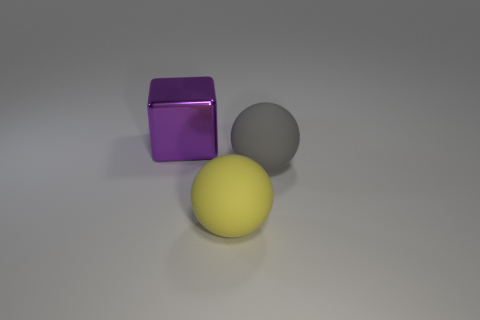How many other objects are there of the same material as the large purple block?
Give a very brief answer. 0. Does the big ball that is on the left side of the large gray ball have the same material as the big gray thing?
Keep it short and to the point. Yes. Are there more large spheres that are left of the yellow ball than purple things that are behind the purple metallic cube?
Keep it short and to the point. No. What number of objects are either large objects that are to the right of the large purple metallic cube or big objects?
Provide a succinct answer. 3. What shape is the big yellow thing that is the same material as the large gray object?
Your answer should be very brief. Sphere. Is there any other thing that is the same shape as the big yellow object?
Your answer should be compact. Yes. There is a large thing that is to the right of the metallic object and behind the big yellow sphere; what is its color?
Your response must be concise. Gray. What number of blocks are either gray things or matte objects?
Provide a succinct answer. 0. How many blue matte balls have the same size as the purple shiny block?
Provide a succinct answer. 0. There is a large sphere behind the yellow object; how many shiny blocks are behind it?
Give a very brief answer. 1. 